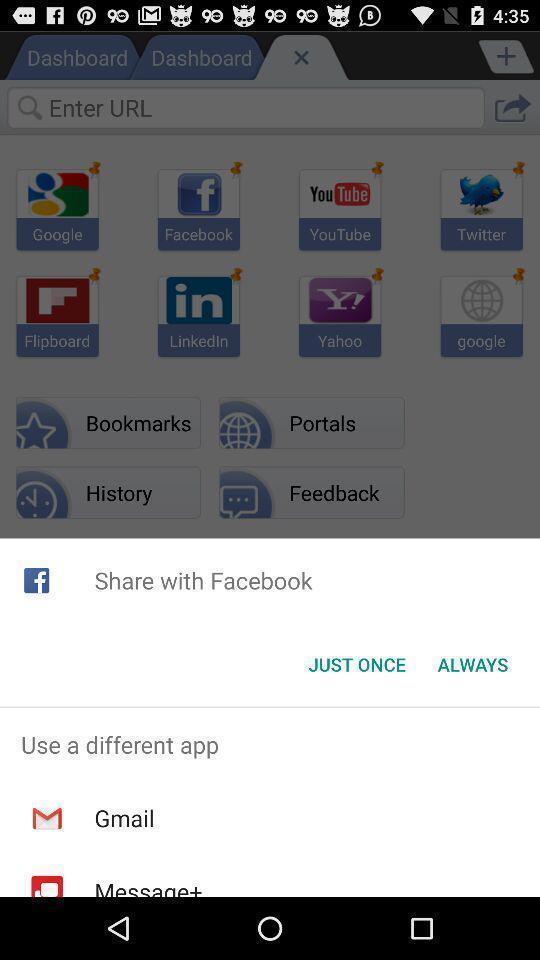Provide a description of this screenshot. Screen with different share options. 